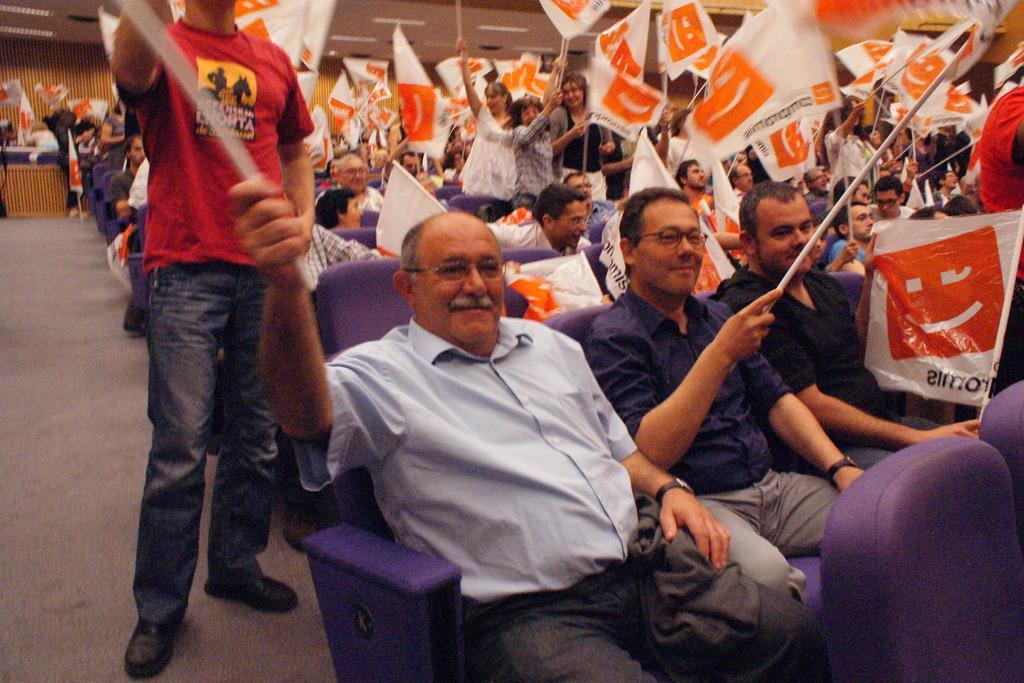Please provide a concise description of this image. In the image we can see there are people sitting on the chair and holding flags in their hand. There are other people standing and they are holding flags in their hand. The chairs are in purple colour. 